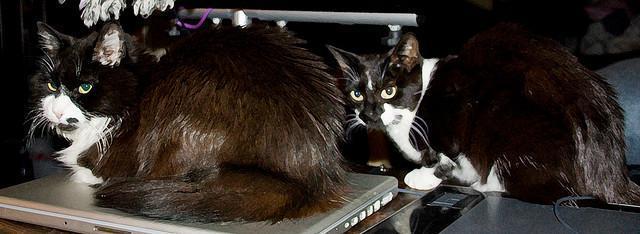How many cats are there?
Give a very brief answer. 2. How many cats are visible?
Give a very brief answer. 2. 